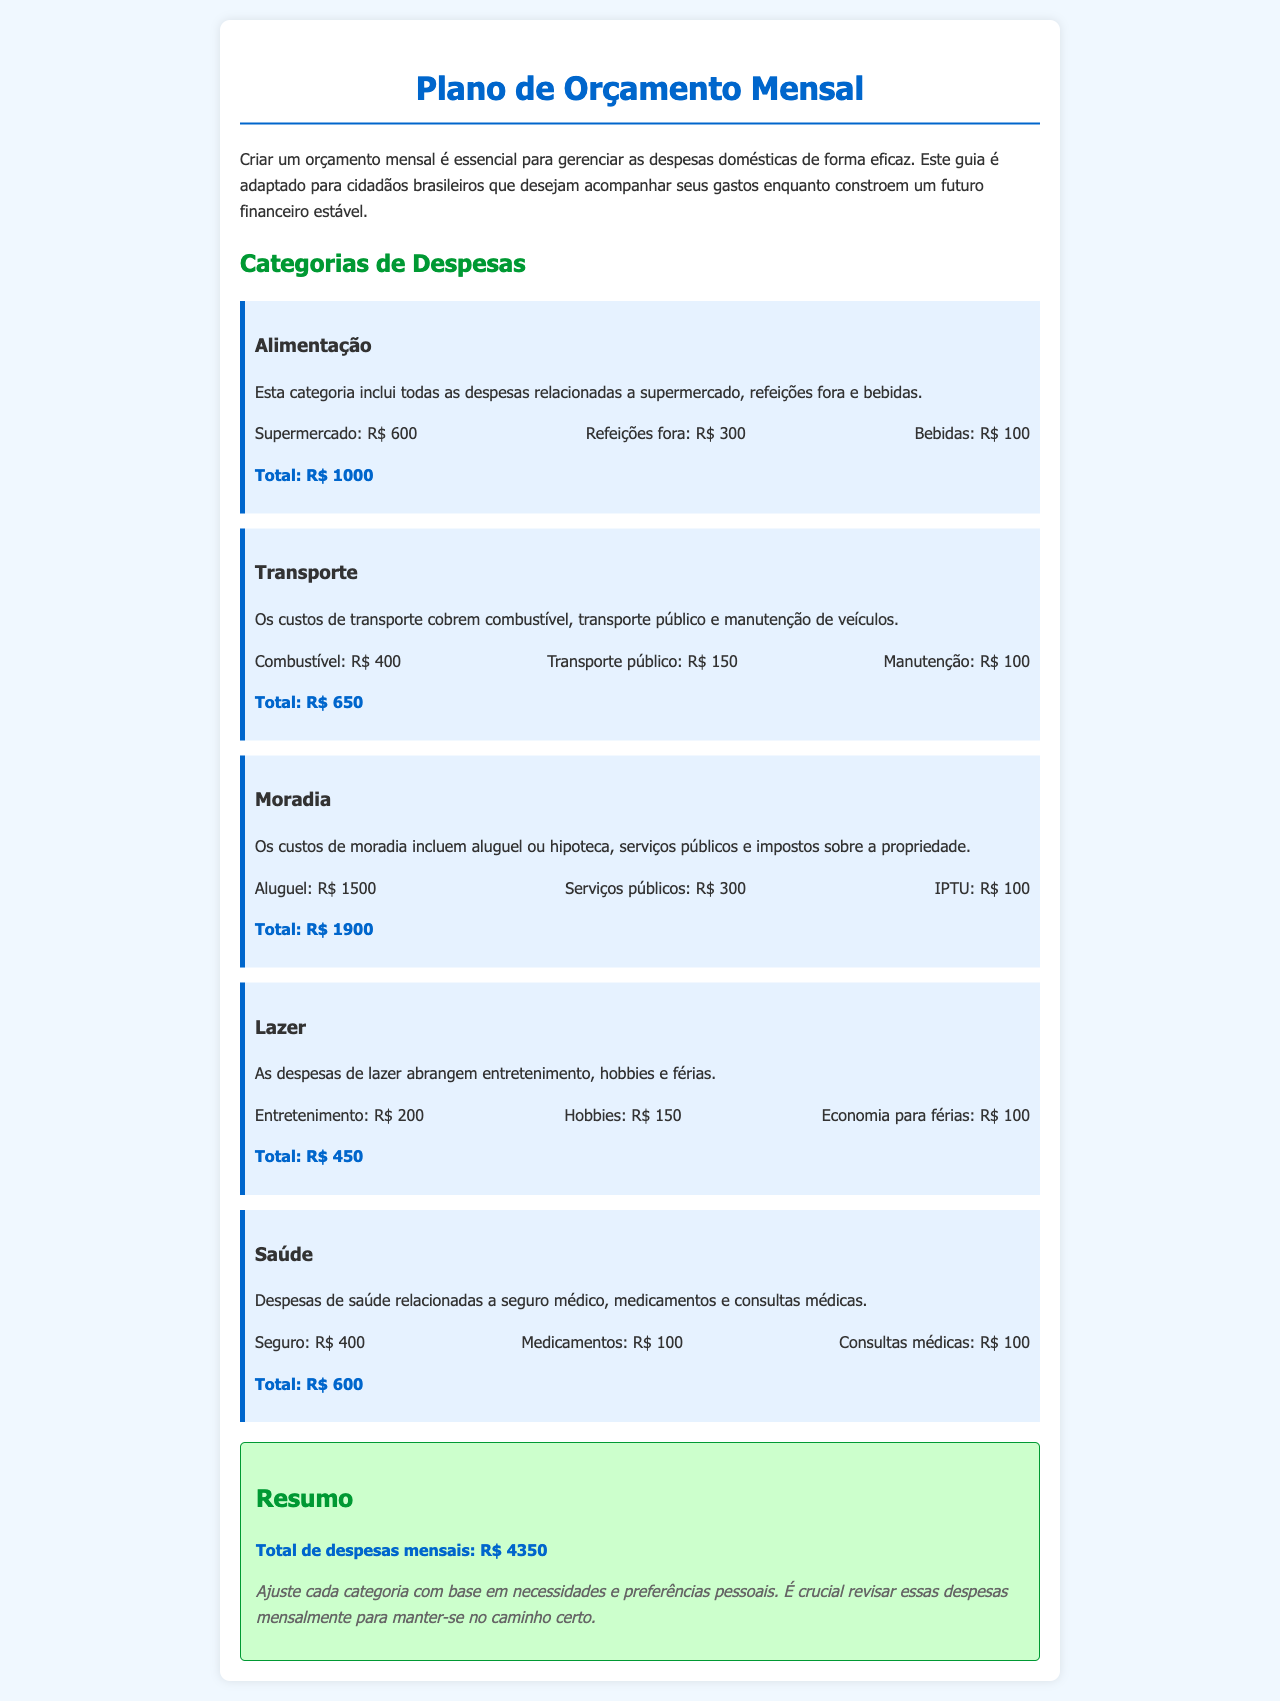qual é o total de despesas em alimentação? O total de despesas em alimentação é obtido somando supermercado, refeições fora e bebidas: R$ 600 + R$ 300 + R$ 100.
Answer: R$ 1000 qual é o custo do transporte público? O custo do transporte público é uma das despesas listadas na categoria Transporte, que é R$ 150.
Answer: R$ 150 qual é o valor do aluguel? O valor do aluguel é mencionado na categoria Moradia, que é R$ 1500.
Answer: R$ 1500 qual é a totalização de despesas em saúde? As despesas em saúde incluem seguro médico, medicamentos e consultas médicas, totalizando R$ 400 + R$ 100 + R$ 100.
Answer: R$ 600 qual é a soma total de despesas mensais? A soma total de despesas mensais é indicada na seção Resumo, que inclui todas as categorias de despesas.
Answer: R$ 4350 como deve ser ajustado o orçamento? O orçamento deve ser ajustado com base em necessidades e preferências pessoais.
Answer: Necessidades e preferências pessoais quais categorias estão incluídas no plano? As categorias incluem Alimentação, Transporte, Moradia, Lazer e Saúde.
Answer: Alimentação, Transporte, Moradia, Lazer, Saúde quantas categorias de despesas são mencionadas? As categorias de despesas mencionadas são cinco, cada uma detalhada no documento.
Answer: 5 